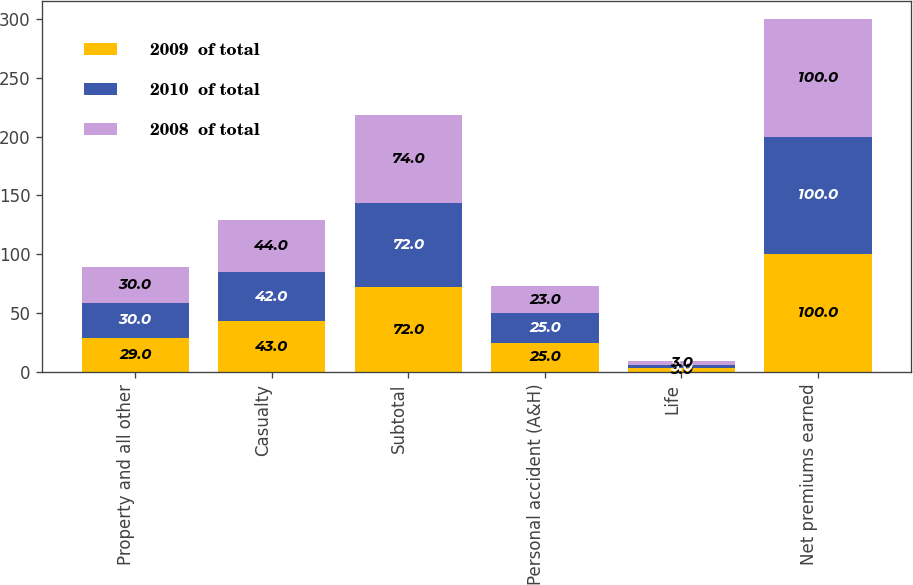Convert chart. <chart><loc_0><loc_0><loc_500><loc_500><stacked_bar_chart><ecel><fcel>Property and all other<fcel>Casualty<fcel>Subtotal<fcel>Personal accident (A&H)<fcel>Life<fcel>Net premiums earned<nl><fcel>2009  of total<fcel>29<fcel>43<fcel>72<fcel>25<fcel>3<fcel>100<nl><fcel>2010  of total<fcel>30<fcel>42<fcel>72<fcel>25<fcel>3<fcel>100<nl><fcel>2008  of total<fcel>30<fcel>44<fcel>74<fcel>23<fcel>3<fcel>100<nl></chart> 